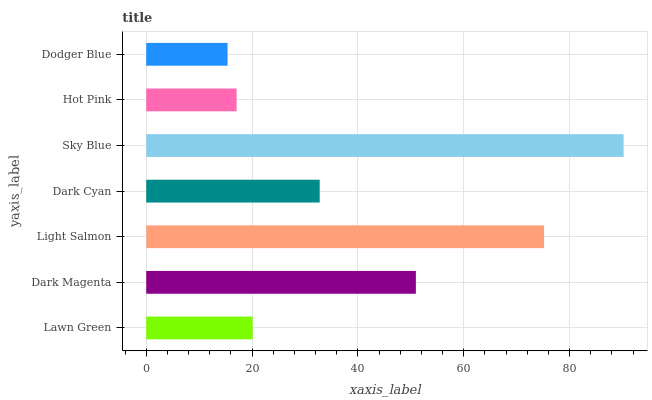Is Dodger Blue the minimum?
Answer yes or no. Yes. Is Sky Blue the maximum?
Answer yes or no. Yes. Is Dark Magenta the minimum?
Answer yes or no. No. Is Dark Magenta the maximum?
Answer yes or no. No. Is Dark Magenta greater than Lawn Green?
Answer yes or no. Yes. Is Lawn Green less than Dark Magenta?
Answer yes or no. Yes. Is Lawn Green greater than Dark Magenta?
Answer yes or no. No. Is Dark Magenta less than Lawn Green?
Answer yes or no. No. Is Dark Cyan the high median?
Answer yes or no. Yes. Is Dark Cyan the low median?
Answer yes or no. Yes. Is Sky Blue the high median?
Answer yes or no. No. Is Light Salmon the low median?
Answer yes or no. No. 